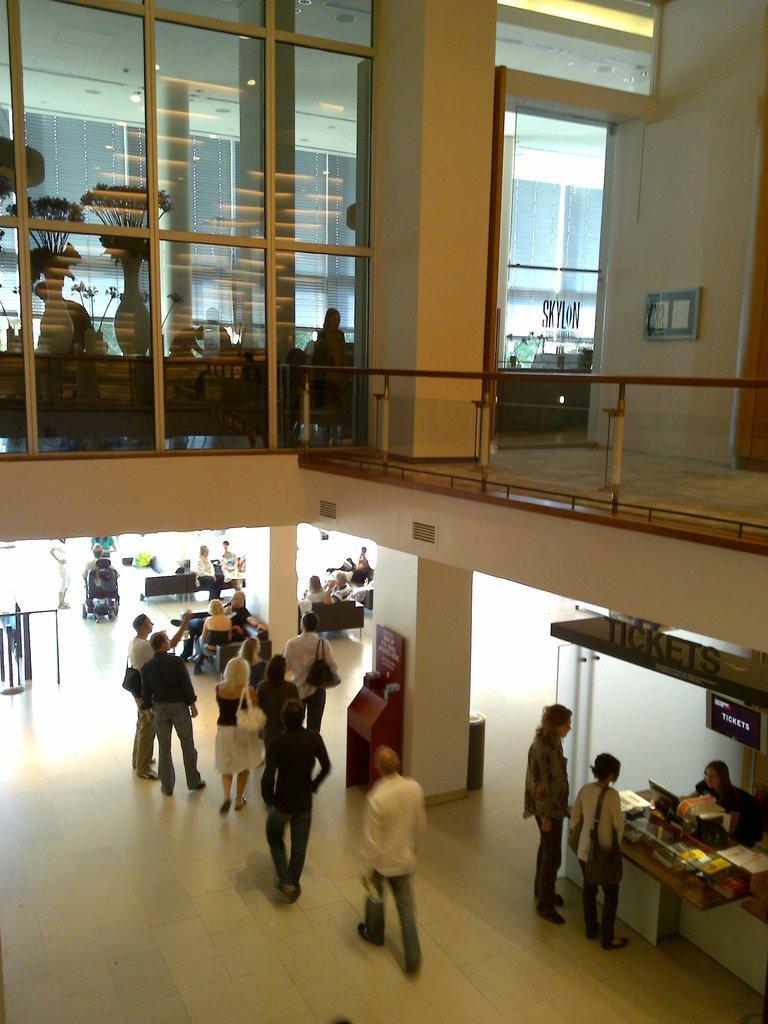In one or two sentences, can you explain what this image depicts? In this image at the bottom there is a man, he wears a white shirt, trouser and shoes, he is walking, in front him there is a man, he wears a black shirt, trouser and shoes, he is walking, in front of them there are many people. On the right there are some people, poster and computer. At the top there are plants, some people, doors, glasses and wall. 